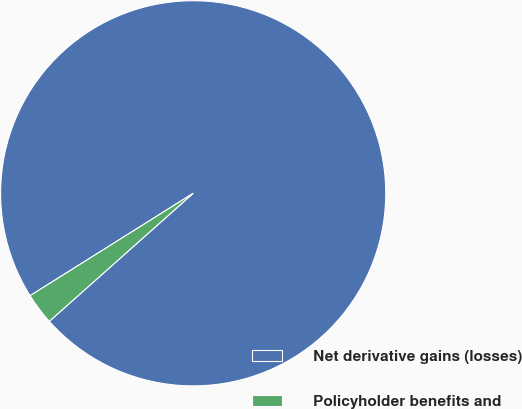Convert chart to OTSL. <chart><loc_0><loc_0><loc_500><loc_500><pie_chart><fcel>Net derivative gains (losses)<fcel>Policyholder benefits and<nl><fcel>97.35%<fcel>2.65%<nl></chart> 